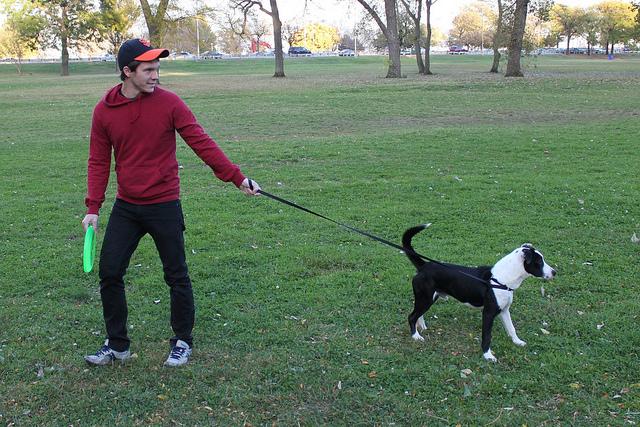What is the man holding in his right hand?
Short answer required. Frisbee. Is the dog going the way it should if it is supposed to be following its master?
Give a very brief answer. No. Is the dog pulling on the leash?
Keep it brief. Yes. 